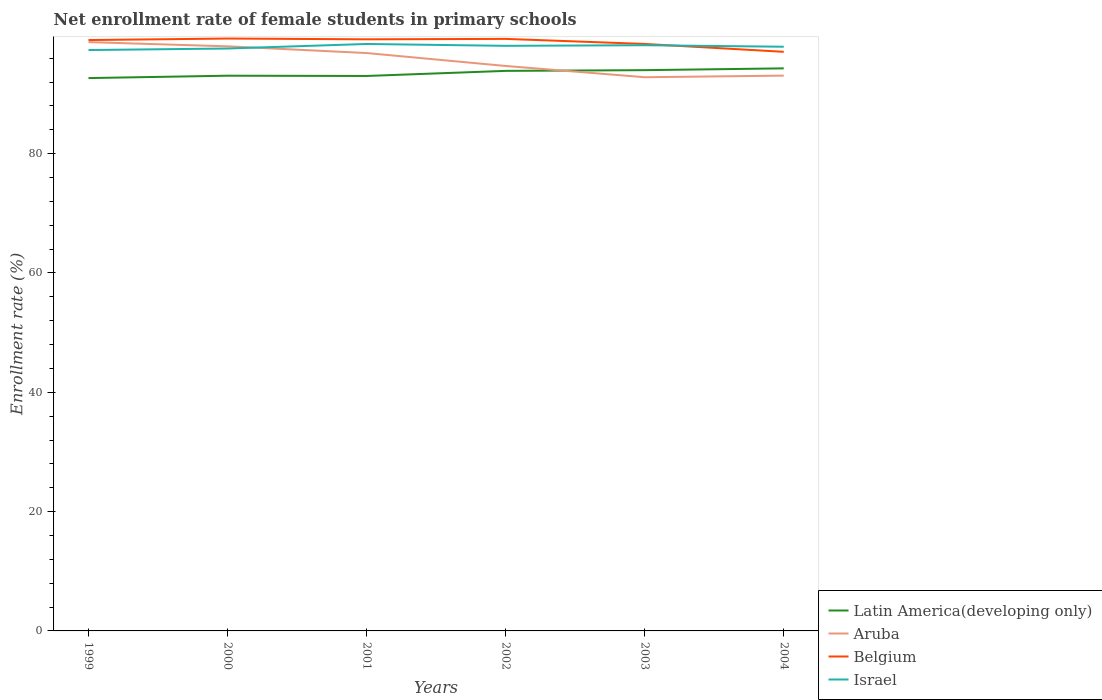How many different coloured lines are there?
Your response must be concise. 4. Does the line corresponding to Latin America(developing only) intersect with the line corresponding to Israel?
Keep it short and to the point. No. Across all years, what is the maximum net enrollment rate of female students in primary schools in Israel?
Make the answer very short. 97.37. What is the total net enrollment rate of female students in primary schools in Israel in the graph?
Provide a short and direct response. 0.31. What is the difference between the highest and the second highest net enrollment rate of female students in primary schools in Aruba?
Your response must be concise. 5.89. Is the net enrollment rate of female students in primary schools in Latin America(developing only) strictly greater than the net enrollment rate of female students in primary schools in Belgium over the years?
Offer a terse response. Yes. How many lines are there?
Offer a terse response. 4. What is the difference between two consecutive major ticks on the Y-axis?
Offer a terse response. 20. Does the graph contain grids?
Make the answer very short. No. Where does the legend appear in the graph?
Ensure brevity in your answer.  Bottom right. How are the legend labels stacked?
Give a very brief answer. Vertical. What is the title of the graph?
Provide a succinct answer. Net enrollment rate of female students in primary schools. What is the label or title of the X-axis?
Keep it short and to the point. Years. What is the label or title of the Y-axis?
Provide a short and direct response. Enrollment rate (%). What is the Enrollment rate (%) in Latin America(developing only) in 1999?
Your answer should be compact. 92.67. What is the Enrollment rate (%) in Aruba in 1999?
Your answer should be very brief. 98.7. What is the Enrollment rate (%) of Belgium in 1999?
Provide a succinct answer. 99.04. What is the Enrollment rate (%) of Israel in 1999?
Your answer should be very brief. 97.37. What is the Enrollment rate (%) of Latin America(developing only) in 2000?
Your answer should be very brief. 93.07. What is the Enrollment rate (%) of Aruba in 2000?
Provide a short and direct response. 97.99. What is the Enrollment rate (%) of Belgium in 2000?
Ensure brevity in your answer.  99.3. What is the Enrollment rate (%) of Israel in 2000?
Offer a very short reply. 97.63. What is the Enrollment rate (%) in Latin America(developing only) in 2001?
Offer a very short reply. 93.02. What is the Enrollment rate (%) of Aruba in 2001?
Your answer should be compact. 96.87. What is the Enrollment rate (%) in Belgium in 2001?
Provide a short and direct response. 99.17. What is the Enrollment rate (%) of Israel in 2001?
Give a very brief answer. 98.39. What is the Enrollment rate (%) of Latin America(developing only) in 2002?
Provide a short and direct response. 93.88. What is the Enrollment rate (%) of Aruba in 2002?
Offer a very short reply. 94.7. What is the Enrollment rate (%) of Belgium in 2002?
Keep it short and to the point. 99.24. What is the Enrollment rate (%) of Israel in 2002?
Your answer should be very brief. 98.08. What is the Enrollment rate (%) in Latin America(developing only) in 2003?
Give a very brief answer. 94. What is the Enrollment rate (%) of Aruba in 2003?
Provide a succinct answer. 92.81. What is the Enrollment rate (%) of Belgium in 2003?
Your answer should be very brief. 98.39. What is the Enrollment rate (%) of Israel in 2003?
Provide a succinct answer. 98.18. What is the Enrollment rate (%) in Latin America(developing only) in 2004?
Ensure brevity in your answer.  94.3. What is the Enrollment rate (%) of Aruba in 2004?
Make the answer very short. 93.08. What is the Enrollment rate (%) in Belgium in 2004?
Give a very brief answer. 97.07. What is the Enrollment rate (%) in Israel in 2004?
Provide a succinct answer. 97.93. Across all years, what is the maximum Enrollment rate (%) in Latin America(developing only)?
Give a very brief answer. 94.3. Across all years, what is the maximum Enrollment rate (%) of Aruba?
Ensure brevity in your answer.  98.7. Across all years, what is the maximum Enrollment rate (%) in Belgium?
Give a very brief answer. 99.3. Across all years, what is the maximum Enrollment rate (%) in Israel?
Provide a succinct answer. 98.39. Across all years, what is the minimum Enrollment rate (%) of Latin America(developing only)?
Offer a terse response. 92.67. Across all years, what is the minimum Enrollment rate (%) in Aruba?
Give a very brief answer. 92.81. Across all years, what is the minimum Enrollment rate (%) in Belgium?
Make the answer very short. 97.07. Across all years, what is the minimum Enrollment rate (%) in Israel?
Your answer should be very brief. 97.37. What is the total Enrollment rate (%) of Latin America(developing only) in the graph?
Offer a very short reply. 560.94. What is the total Enrollment rate (%) in Aruba in the graph?
Offer a very short reply. 574.16. What is the total Enrollment rate (%) in Belgium in the graph?
Ensure brevity in your answer.  592.21. What is the total Enrollment rate (%) of Israel in the graph?
Keep it short and to the point. 587.56. What is the difference between the Enrollment rate (%) of Latin America(developing only) in 1999 and that in 2000?
Your response must be concise. -0.4. What is the difference between the Enrollment rate (%) of Aruba in 1999 and that in 2000?
Keep it short and to the point. 0.71. What is the difference between the Enrollment rate (%) of Belgium in 1999 and that in 2000?
Your answer should be very brief. -0.25. What is the difference between the Enrollment rate (%) in Israel in 1999 and that in 2000?
Give a very brief answer. -0.26. What is the difference between the Enrollment rate (%) in Latin America(developing only) in 1999 and that in 2001?
Offer a terse response. -0.35. What is the difference between the Enrollment rate (%) of Aruba in 1999 and that in 2001?
Ensure brevity in your answer.  1.83. What is the difference between the Enrollment rate (%) in Belgium in 1999 and that in 2001?
Provide a succinct answer. -0.12. What is the difference between the Enrollment rate (%) in Israel in 1999 and that in 2001?
Make the answer very short. -1.02. What is the difference between the Enrollment rate (%) of Latin America(developing only) in 1999 and that in 2002?
Give a very brief answer. -1.21. What is the difference between the Enrollment rate (%) in Aruba in 1999 and that in 2002?
Your answer should be compact. 4. What is the difference between the Enrollment rate (%) of Belgium in 1999 and that in 2002?
Offer a very short reply. -0.19. What is the difference between the Enrollment rate (%) in Israel in 1999 and that in 2002?
Offer a terse response. -0.71. What is the difference between the Enrollment rate (%) in Latin America(developing only) in 1999 and that in 2003?
Give a very brief answer. -1.33. What is the difference between the Enrollment rate (%) of Aruba in 1999 and that in 2003?
Offer a very short reply. 5.89. What is the difference between the Enrollment rate (%) in Belgium in 1999 and that in 2003?
Ensure brevity in your answer.  0.65. What is the difference between the Enrollment rate (%) of Israel in 1999 and that in 2003?
Provide a succinct answer. -0.81. What is the difference between the Enrollment rate (%) of Latin America(developing only) in 1999 and that in 2004?
Keep it short and to the point. -1.63. What is the difference between the Enrollment rate (%) of Aruba in 1999 and that in 2004?
Provide a short and direct response. 5.62. What is the difference between the Enrollment rate (%) of Belgium in 1999 and that in 2004?
Provide a short and direct response. 1.97. What is the difference between the Enrollment rate (%) in Israel in 1999 and that in 2004?
Make the answer very short. -0.56. What is the difference between the Enrollment rate (%) of Latin America(developing only) in 2000 and that in 2001?
Your answer should be very brief. 0.05. What is the difference between the Enrollment rate (%) of Aruba in 2000 and that in 2001?
Offer a very short reply. 1.13. What is the difference between the Enrollment rate (%) in Belgium in 2000 and that in 2001?
Your answer should be compact. 0.13. What is the difference between the Enrollment rate (%) of Israel in 2000 and that in 2001?
Provide a succinct answer. -0.76. What is the difference between the Enrollment rate (%) of Latin America(developing only) in 2000 and that in 2002?
Provide a succinct answer. -0.81. What is the difference between the Enrollment rate (%) in Aruba in 2000 and that in 2002?
Provide a short and direct response. 3.29. What is the difference between the Enrollment rate (%) of Belgium in 2000 and that in 2002?
Your answer should be compact. 0.06. What is the difference between the Enrollment rate (%) in Israel in 2000 and that in 2002?
Give a very brief answer. -0.45. What is the difference between the Enrollment rate (%) in Latin America(developing only) in 2000 and that in 2003?
Keep it short and to the point. -0.93. What is the difference between the Enrollment rate (%) in Aruba in 2000 and that in 2003?
Your answer should be compact. 5.18. What is the difference between the Enrollment rate (%) of Belgium in 2000 and that in 2003?
Make the answer very short. 0.91. What is the difference between the Enrollment rate (%) in Israel in 2000 and that in 2003?
Your answer should be compact. -0.55. What is the difference between the Enrollment rate (%) of Latin America(developing only) in 2000 and that in 2004?
Give a very brief answer. -1.23. What is the difference between the Enrollment rate (%) of Aruba in 2000 and that in 2004?
Your response must be concise. 4.91. What is the difference between the Enrollment rate (%) of Belgium in 2000 and that in 2004?
Provide a succinct answer. 2.22. What is the difference between the Enrollment rate (%) in Israel in 2000 and that in 2004?
Ensure brevity in your answer.  -0.3. What is the difference between the Enrollment rate (%) in Latin America(developing only) in 2001 and that in 2002?
Offer a terse response. -0.85. What is the difference between the Enrollment rate (%) of Aruba in 2001 and that in 2002?
Make the answer very short. 2.17. What is the difference between the Enrollment rate (%) in Belgium in 2001 and that in 2002?
Offer a very short reply. -0.07. What is the difference between the Enrollment rate (%) in Israel in 2001 and that in 2002?
Make the answer very short. 0.31. What is the difference between the Enrollment rate (%) in Latin America(developing only) in 2001 and that in 2003?
Ensure brevity in your answer.  -0.98. What is the difference between the Enrollment rate (%) of Aruba in 2001 and that in 2003?
Your response must be concise. 4.05. What is the difference between the Enrollment rate (%) in Belgium in 2001 and that in 2003?
Give a very brief answer. 0.78. What is the difference between the Enrollment rate (%) of Israel in 2001 and that in 2003?
Your answer should be very brief. 0.21. What is the difference between the Enrollment rate (%) of Latin America(developing only) in 2001 and that in 2004?
Provide a succinct answer. -1.27. What is the difference between the Enrollment rate (%) of Aruba in 2001 and that in 2004?
Your answer should be compact. 3.78. What is the difference between the Enrollment rate (%) of Belgium in 2001 and that in 2004?
Make the answer very short. 2.1. What is the difference between the Enrollment rate (%) in Israel in 2001 and that in 2004?
Provide a short and direct response. 0.46. What is the difference between the Enrollment rate (%) in Latin America(developing only) in 2002 and that in 2003?
Your answer should be compact. -0.12. What is the difference between the Enrollment rate (%) in Aruba in 2002 and that in 2003?
Your answer should be very brief. 1.89. What is the difference between the Enrollment rate (%) in Belgium in 2002 and that in 2003?
Give a very brief answer. 0.85. What is the difference between the Enrollment rate (%) in Israel in 2002 and that in 2003?
Offer a terse response. -0.1. What is the difference between the Enrollment rate (%) in Latin America(developing only) in 2002 and that in 2004?
Offer a terse response. -0.42. What is the difference between the Enrollment rate (%) in Aruba in 2002 and that in 2004?
Offer a very short reply. 1.62. What is the difference between the Enrollment rate (%) of Belgium in 2002 and that in 2004?
Make the answer very short. 2.17. What is the difference between the Enrollment rate (%) in Israel in 2002 and that in 2004?
Your answer should be compact. 0.15. What is the difference between the Enrollment rate (%) of Latin America(developing only) in 2003 and that in 2004?
Your response must be concise. -0.3. What is the difference between the Enrollment rate (%) of Aruba in 2003 and that in 2004?
Make the answer very short. -0.27. What is the difference between the Enrollment rate (%) of Belgium in 2003 and that in 2004?
Offer a very short reply. 1.32. What is the difference between the Enrollment rate (%) in Israel in 2003 and that in 2004?
Offer a very short reply. 0.25. What is the difference between the Enrollment rate (%) of Latin America(developing only) in 1999 and the Enrollment rate (%) of Aruba in 2000?
Provide a short and direct response. -5.32. What is the difference between the Enrollment rate (%) in Latin America(developing only) in 1999 and the Enrollment rate (%) in Belgium in 2000?
Your answer should be very brief. -6.62. What is the difference between the Enrollment rate (%) of Latin America(developing only) in 1999 and the Enrollment rate (%) of Israel in 2000?
Your answer should be very brief. -4.96. What is the difference between the Enrollment rate (%) of Aruba in 1999 and the Enrollment rate (%) of Belgium in 2000?
Your response must be concise. -0.6. What is the difference between the Enrollment rate (%) in Aruba in 1999 and the Enrollment rate (%) in Israel in 2000?
Make the answer very short. 1.07. What is the difference between the Enrollment rate (%) in Belgium in 1999 and the Enrollment rate (%) in Israel in 2000?
Provide a succinct answer. 1.42. What is the difference between the Enrollment rate (%) in Latin America(developing only) in 1999 and the Enrollment rate (%) in Aruba in 2001?
Ensure brevity in your answer.  -4.2. What is the difference between the Enrollment rate (%) of Latin America(developing only) in 1999 and the Enrollment rate (%) of Belgium in 2001?
Provide a succinct answer. -6.5. What is the difference between the Enrollment rate (%) of Latin America(developing only) in 1999 and the Enrollment rate (%) of Israel in 2001?
Make the answer very short. -5.72. What is the difference between the Enrollment rate (%) in Aruba in 1999 and the Enrollment rate (%) in Belgium in 2001?
Make the answer very short. -0.47. What is the difference between the Enrollment rate (%) in Aruba in 1999 and the Enrollment rate (%) in Israel in 2001?
Your answer should be very brief. 0.31. What is the difference between the Enrollment rate (%) in Belgium in 1999 and the Enrollment rate (%) in Israel in 2001?
Your response must be concise. 0.66. What is the difference between the Enrollment rate (%) of Latin America(developing only) in 1999 and the Enrollment rate (%) of Aruba in 2002?
Offer a terse response. -2.03. What is the difference between the Enrollment rate (%) in Latin America(developing only) in 1999 and the Enrollment rate (%) in Belgium in 2002?
Your answer should be very brief. -6.57. What is the difference between the Enrollment rate (%) of Latin America(developing only) in 1999 and the Enrollment rate (%) of Israel in 2002?
Your response must be concise. -5.4. What is the difference between the Enrollment rate (%) in Aruba in 1999 and the Enrollment rate (%) in Belgium in 2002?
Your response must be concise. -0.54. What is the difference between the Enrollment rate (%) of Aruba in 1999 and the Enrollment rate (%) of Israel in 2002?
Offer a terse response. 0.62. What is the difference between the Enrollment rate (%) in Belgium in 1999 and the Enrollment rate (%) in Israel in 2002?
Make the answer very short. 0.97. What is the difference between the Enrollment rate (%) in Latin America(developing only) in 1999 and the Enrollment rate (%) in Aruba in 2003?
Offer a very short reply. -0.14. What is the difference between the Enrollment rate (%) of Latin America(developing only) in 1999 and the Enrollment rate (%) of Belgium in 2003?
Provide a short and direct response. -5.72. What is the difference between the Enrollment rate (%) in Latin America(developing only) in 1999 and the Enrollment rate (%) in Israel in 2003?
Your answer should be compact. -5.51. What is the difference between the Enrollment rate (%) of Aruba in 1999 and the Enrollment rate (%) of Belgium in 2003?
Offer a very short reply. 0.31. What is the difference between the Enrollment rate (%) in Aruba in 1999 and the Enrollment rate (%) in Israel in 2003?
Provide a succinct answer. 0.52. What is the difference between the Enrollment rate (%) in Belgium in 1999 and the Enrollment rate (%) in Israel in 2003?
Offer a very short reply. 0.87. What is the difference between the Enrollment rate (%) of Latin America(developing only) in 1999 and the Enrollment rate (%) of Aruba in 2004?
Give a very brief answer. -0.41. What is the difference between the Enrollment rate (%) in Latin America(developing only) in 1999 and the Enrollment rate (%) in Belgium in 2004?
Give a very brief answer. -4.4. What is the difference between the Enrollment rate (%) of Latin America(developing only) in 1999 and the Enrollment rate (%) of Israel in 2004?
Offer a very short reply. -5.25. What is the difference between the Enrollment rate (%) of Aruba in 1999 and the Enrollment rate (%) of Belgium in 2004?
Provide a short and direct response. 1.63. What is the difference between the Enrollment rate (%) of Aruba in 1999 and the Enrollment rate (%) of Israel in 2004?
Make the answer very short. 0.77. What is the difference between the Enrollment rate (%) in Belgium in 1999 and the Enrollment rate (%) in Israel in 2004?
Make the answer very short. 1.12. What is the difference between the Enrollment rate (%) of Latin America(developing only) in 2000 and the Enrollment rate (%) of Aruba in 2001?
Ensure brevity in your answer.  -3.8. What is the difference between the Enrollment rate (%) in Latin America(developing only) in 2000 and the Enrollment rate (%) in Belgium in 2001?
Provide a short and direct response. -6.1. What is the difference between the Enrollment rate (%) in Latin America(developing only) in 2000 and the Enrollment rate (%) in Israel in 2001?
Your answer should be compact. -5.32. What is the difference between the Enrollment rate (%) of Aruba in 2000 and the Enrollment rate (%) of Belgium in 2001?
Ensure brevity in your answer.  -1.18. What is the difference between the Enrollment rate (%) of Aruba in 2000 and the Enrollment rate (%) of Israel in 2001?
Offer a very short reply. -0.4. What is the difference between the Enrollment rate (%) of Belgium in 2000 and the Enrollment rate (%) of Israel in 2001?
Keep it short and to the point. 0.91. What is the difference between the Enrollment rate (%) of Latin America(developing only) in 2000 and the Enrollment rate (%) of Aruba in 2002?
Your answer should be very brief. -1.63. What is the difference between the Enrollment rate (%) in Latin America(developing only) in 2000 and the Enrollment rate (%) in Belgium in 2002?
Give a very brief answer. -6.17. What is the difference between the Enrollment rate (%) of Latin America(developing only) in 2000 and the Enrollment rate (%) of Israel in 2002?
Your response must be concise. -5.01. What is the difference between the Enrollment rate (%) in Aruba in 2000 and the Enrollment rate (%) in Belgium in 2002?
Your answer should be compact. -1.25. What is the difference between the Enrollment rate (%) in Aruba in 2000 and the Enrollment rate (%) in Israel in 2002?
Provide a succinct answer. -0.08. What is the difference between the Enrollment rate (%) of Belgium in 2000 and the Enrollment rate (%) of Israel in 2002?
Give a very brief answer. 1.22. What is the difference between the Enrollment rate (%) in Latin America(developing only) in 2000 and the Enrollment rate (%) in Aruba in 2003?
Make the answer very short. 0.26. What is the difference between the Enrollment rate (%) in Latin America(developing only) in 2000 and the Enrollment rate (%) in Belgium in 2003?
Your response must be concise. -5.32. What is the difference between the Enrollment rate (%) of Latin America(developing only) in 2000 and the Enrollment rate (%) of Israel in 2003?
Make the answer very short. -5.11. What is the difference between the Enrollment rate (%) of Aruba in 2000 and the Enrollment rate (%) of Belgium in 2003?
Your answer should be very brief. -0.4. What is the difference between the Enrollment rate (%) of Aruba in 2000 and the Enrollment rate (%) of Israel in 2003?
Provide a succinct answer. -0.18. What is the difference between the Enrollment rate (%) of Belgium in 2000 and the Enrollment rate (%) of Israel in 2003?
Give a very brief answer. 1.12. What is the difference between the Enrollment rate (%) in Latin America(developing only) in 2000 and the Enrollment rate (%) in Aruba in 2004?
Ensure brevity in your answer.  -0.02. What is the difference between the Enrollment rate (%) of Latin America(developing only) in 2000 and the Enrollment rate (%) of Belgium in 2004?
Your answer should be very brief. -4. What is the difference between the Enrollment rate (%) of Latin America(developing only) in 2000 and the Enrollment rate (%) of Israel in 2004?
Your answer should be compact. -4.86. What is the difference between the Enrollment rate (%) of Aruba in 2000 and the Enrollment rate (%) of Belgium in 2004?
Offer a terse response. 0.92. What is the difference between the Enrollment rate (%) of Aruba in 2000 and the Enrollment rate (%) of Israel in 2004?
Offer a very short reply. 0.07. What is the difference between the Enrollment rate (%) of Belgium in 2000 and the Enrollment rate (%) of Israel in 2004?
Make the answer very short. 1.37. What is the difference between the Enrollment rate (%) in Latin America(developing only) in 2001 and the Enrollment rate (%) in Aruba in 2002?
Provide a short and direct response. -1.68. What is the difference between the Enrollment rate (%) in Latin America(developing only) in 2001 and the Enrollment rate (%) in Belgium in 2002?
Your response must be concise. -6.22. What is the difference between the Enrollment rate (%) of Latin America(developing only) in 2001 and the Enrollment rate (%) of Israel in 2002?
Your answer should be compact. -5.05. What is the difference between the Enrollment rate (%) in Aruba in 2001 and the Enrollment rate (%) in Belgium in 2002?
Your answer should be very brief. -2.37. What is the difference between the Enrollment rate (%) of Aruba in 2001 and the Enrollment rate (%) of Israel in 2002?
Provide a short and direct response. -1.21. What is the difference between the Enrollment rate (%) of Belgium in 2001 and the Enrollment rate (%) of Israel in 2002?
Your response must be concise. 1.09. What is the difference between the Enrollment rate (%) of Latin America(developing only) in 2001 and the Enrollment rate (%) of Aruba in 2003?
Make the answer very short. 0.21. What is the difference between the Enrollment rate (%) of Latin America(developing only) in 2001 and the Enrollment rate (%) of Belgium in 2003?
Keep it short and to the point. -5.37. What is the difference between the Enrollment rate (%) in Latin America(developing only) in 2001 and the Enrollment rate (%) in Israel in 2003?
Your answer should be compact. -5.15. What is the difference between the Enrollment rate (%) of Aruba in 2001 and the Enrollment rate (%) of Belgium in 2003?
Provide a succinct answer. -1.52. What is the difference between the Enrollment rate (%) of Aruba in 2001 and the Enrollment rate (%) of Israel in 2003?
Offer a terse response. -1.31. What is the difference between the Enrollment rate (%) in Latin America(developing only) in 2001 and the Enrollment rate (%) in Aruba in 2004?
Offer a very short reply. -0.06. What is the difference between the Enrollment rate (%) of Latin America(developing only) in 2001 and the Enrollment rate (%) of Belgium in 2004?
Offer a terse response. -4.05. What is the difference between the Enrollment rate (%) in Latin America(developing only) in 2001 and the Enrollment rate (%) in Israel in 2004?
Your response must be concise. -4.9. What is the difference between the Enrollment rate (%) in Aruba in 2001 and the Enrollment rate (%) in Belgium in 2004?
Your response must be concise. -0.21. What is the difference between the Enrollment rate (%) in Aruba in 2001 and the Enrollment rate (%) in Israel in 2004?
Give a very brief answer. -1.06. What is the difference between the Enrollment rate (%) of Belgium in 2001 and the Enrollment rate (%) of Israel in 2004?
Offer a very short reply. 1.24. What is the difference between the Enrollment rate (%) of Latin America(developing only) in 2002 and the Enrollment rate (%) of Aruba in 2003?
Keep it short and to the point. 1.06. What is the difference between the Enrollment rate (%) in Latin America(developing only) in 2002 and the Enrollment rate (%) in Belgium in 2003?
Your response must be concise. -4.51. What is the difference between the Enrollment rate (%) of Latin America(developing only) in 2002 and the Enrollment rate (%) of Israel in 2003?
Your response must be concise. -4.3. What is the difference between the Enrollment rate (%) of Aruba in 2002 and the Enrollment rate (%) of Belgium in 2003?
Your answer should be compact. -3.69. What is the difference between the Enrollment rate (%) of Aruba in 2002 and the Enrollment rate (%) of Israel in 2003?
Ensure brevity in your answer.  -3.48. What is the difference between the Enrollment rate (%) of Belgium in 2002 and the Enrollment rate (%) of Israel in 2003?
Make the answer very short. 1.06. What is the difference between the Enrollment rate (%) in Latin America(developing only) in 2002 and the Enrollment rate (%) in Aruba in 2004?
Offer a very short reply. 0.79. What is the difference between the Enrollment rate (%) in Latin America(developing only) in 2002 and the Enrollment rate (%) in Belgium in 2004?
Provide a short and direct response. -3.2. What is the difference between the Enrollment rate (%) in Latin America(developing only) in 2002 and the Enrollment rate (%) in Israel in 2004?
Your answer should be very brief. -4.05. What is the difference between the Enrollment rate (%) of Aruba in 2002 and the Enrollment rate (%) of Belgium in 2004?
Your answer should be compact. -2.37. What is the difference between the Enrollment rate (%) in Aruba in 2002 and the Enrollment rate (%) in Israel in 2004?
Offer a very short reply. -3.23. What is the difference between the Enrollment rate (%) of Belgium in 2002 and the Enrollment rate (%) of Israel in 2004?
Give a very brief answer. 1.31. What is the difference between the Enrollment rate (%) of Latin America(developing only) in 2003 and the Enrollment rate (%) of Aruba in 2004?
Your answer should be very brief. 0.91. What is the difference between the Enrollment rate (%) in Latin America(developing only) in 2003 and the Enrollment rate (%) in Belgium in 2004?
Make the answer very short. -3.07. What is the difference between the Enrollment rate (%) of Latin America(developing only) in 2003 and the Enrollment rate (%) of Israel in 2004?
Give a very brief answer. -3.93. What is the difference between the Enrollment rate (%) of Aruba in 2003 and the Enrollment rate (%) of Belgium in 2004?
Provide a succinct answer. -4.26. What is the difference between the Enrollment rate (%) in Aruba in 2003 and the Enrollment rate (%) in Israel in 2004?
Your answer should be compact. -5.11. What is the difference between the Enrollment rate (%) of Belgium in 2003 and the Enrollment rate (%) of Israel in 2004?
Your response must be concise. 0.46. What is the average Enrollment rate (%) in Latin America(developing only) per year?
Your response must be concise. 93.49. What is the average Enrollment rate (%) in Aruba per year?
Keep it short and to the point. 95.69. What is the average Enrollment rate (%) of Belgium per year?
Offer a terse response. 98.7. What is the average Enrollment rate (%) of Israel per year?
Offer a terse response. 97.93. In the year 1999, what is the difference between the Enrollment rate (%) in Latin America(developing only) and Enrollment rate (%) in Aruba?
Make the answer very short. -6.03. In the year 1999, what is the difference between the Enrollment rate (%) in Latin America(developing only) and Enrollment rate (%) in Belgium?
Your response must be concise. -6.37. In the year 1999, what is the difference between the Enrollment rate (%) in Latin America(developing only) and Enrollment rate (%) in Israel?
Offer a very short reply. -4.7. In the year 1999, what is the difference between the Enrollment rate (%) of Aruba and Enrollment rate (%) of Belgium?
Provide a short and direct response. -0.35. In the year 1999, what is the difference between the Enrollment rate (%) of Aruba and Enrollment rate (%) of Israel?
Keep it short and to the point. 1.33. In the year 1999, what is the difference between the Enrollment rate (%) in Belgium and Enrollment rate (%) in Israel?
Give a very brief answer. 1.68. In the year 2000, what is the difference between the Enrollment rate (%) of Latin America(developing only) and Enrollment rate (%) of Aruba?
Your answer should be compact. -4.92. In the year 2000, what is the difference between the Enrollment rate (%) of Latin America(developing only) and Enrollment rate (%) of Belgium?
Ensure brevity in your answer.  -6.23. In the year 2000, what is the difference between the Enrollment rate (%) of Latin America(developing only) and Enrollment rate (%) of Israel?
Give a very brief answer. -4.56. In the year 2000, what is the difference between the Enrollment rate (%) of Aruba and Enrollment rate (%) of Belgium?
Offer a very short reply. -1.3. In the year 2000, what is the difference between the Enrollment rate (%) of Aruba and Enrollment rate (%) of Israel?
Offer a terse response. 0.37. In the year 2000, what is the difference between the Enrollment rate (%) of Belgium and Enrollment rate (%) of Israel?
Provide a succinct answer. 1.67. In the year 2001, what is the difference between the Enrollment rate (%) in Latin America(developing only) and Enrollment rate (%) in Aruba?
Offer a very short reply. -3.84. In the year 2001, what is the difference between the Enrollment rate (%) in Latin America(developing only) and Enrollment rate (%) in Belgium?
Keep it short and to the point. -6.15. In the year 2001, what is the difference between the Enrollment rate (%) in Latin America(developing only) and Enrollment rate (%) in Israel?
Your answer should be very brief. -5.37. In the year 2001, what is the difference between the Enrollment rate (%) in Aruba and Enrollment rate (%) in Belgium?
Make the answer very short. -2.3. In the year 2001, what is the difference between the Enrollment rate (%) in Aruba and Enrollment rate (%) in Israel?
Your answer should be very brief. -1.52. In the year 2001, what is the difference between the Enrollment rate (%) in Belgium and Enrollment rate (%) in Israel?
Provide a short and direct response. 0.78. In the year 2002, what is the difference between the Enrollment rate (%) in Latin America(developing only) and Enrollment rate (%) in Aruba?
Provide a short and direct response. -0.82. In the year 2002, what is the difference between the Enrollment rate (%) of Latin America(developing only) and Enrollment rate (%) of Belgium?
Provide a short and direct response. -5.36. In the year 2002, what is the difference between the Enrollment rate (%) of Latin America(developing only) and Enrollment rate (%) of Israel?
Provide a short and direct response. -4.2. In the year 2002, what is the difference between the Enrollment rate (%) of Aruba and Enrollment rate (%) of Belgium?
Ensure brevity in your answer.  -4.54. In the year 2002, what is the difference between the Enrollment rate (%) of Aruba and Enrollment rate (%) of Israel?
Your answer should be compact. -3.38. In the year 2002, what is the difference between the Enrollment rate (%) of Belgium and Enrollment rate (%) of Israel?
Provide a short and direct response. 1.16. In the year 2003, what is the difference between the Enrollment rate (%) in Latin America(developing only) and Enrollment rate (%) in Aruba?
Offer a terse response. 1.19. In the year 2003, what is the difference between the Enrollment rate (%) in Latin America(developing only) and Enrollment rate (%) in Belgium?
Your response must be concise. -4.39. In the year 2003, what is the difference between the Enrollment rate (%) of Latin America(developing only) and Enrollment rate (%) of Israel?
Ensure brevity in your answer.  -4.18. In the year 2003, what is the difference between the Enrollment rate (%) of Aruba and Enrollment rate (%) of Belgium?
Your answer should be compact. -5.58. In the year 2003, what is the difference between the Enrollment rate (%) of Aruba and Enrollment rate (%) of Israel?
Your answer should be very brief. -5.36. In the year 2003, what is the difference between the Enrollment rate (%) of Belgium and Enrollment rate (%) of Israel?
Provide a short and direct response. 0.21. In the year 2004, what is the difference between the Enrollment rate (%) in Latin America(developing only) and Enrollment rate (%) in Aruba?
Offer a very short reply. 1.21. In the year 2004, what is the difference between the Enrollment rate (%) in Latin America(developing only) and Enrollment rate (%) in Belgium?
Ensure brevity in your answer.  -2.77. In the year 2004, what is the difference between the Enrollment rate (%) of Latin America(developing only) and Enrollment rate (%) of Israel?
Your response must be concise. -3.63. In the year 2004, what is the difference between the Enrollment rate (%) of Aruba and Enrollment rate (%) of Belgium?
Provide a short and direct response. -3.99. In the year 2004, what is the difference between the Enrollment rate (%) in Aruba and Enrollment rate (%) in Israel?
Your answer should be very brief. -4.84. In the year 2004, what is the difference between the Enrollment rate (%) in Belgium and Enrollment rate (%) in Israel?
Keep it short and to the point. -0.85. What is the ratio of the Enrollment rate (%) in Latin America(developing only) in 1999 to that in 2001?
Make the answer very short. 1. What is the ratio of the Enrollment rate (%) in Aruba in 1999 to that in 2001?
Provide a short and direct response. 1.02. What is the ratio of the Enrollment rate (%) in Latin America(developing only) in 1999 to that in 2002?
Provide a succinct answer. 0.99. What is the ratio of the Enrollment rate (%) in Aruba in 1999 to that in 2002?
Provide a succinct answer. 1.04. What is the ratio of the Enrollment rate (%) in Belgium in 1999 to that in 2002?
Your response must be concise. 1. What is the ratio of the Enrollment rate (%) in Israel in 1999 to that in 2002?
Offer a very short reply. 0.99. What is the ratio of the Enrollment rate (%) in Latin America(developing only) in 1999 to that in 2003?
Your answer should be compact. 0.99. What is the ratio of the Enrollment rate (%) in Aruba in 1999 to that in 2003?
Provide a succinct answer. 1.06. What is the ratio of the Enrollment rate (%) of Israel in 1999 to that in 2003?
Ensure brevity in your answer.  0.99. What is the ratio of the Enrollment rate (%) in Latin America(developing only) in 1999 to that in 2004?
Make the answer very short. 0.98. What is the ratio of the Enrollment rate (%) in Aruba in 1999 to that in 2004?
Your answer should be very brief. 1.06. What is the ratio of the Enrollment rate (%) of Belgium in 1999 to that in 2004?
Make the answer very short. 1.02. What is the ratio of the Enrollment rate (%) in Aruba in 2000 to that in 2001?
Provide a succinct answer. 1.01. What is the ratio of the Enrollment rate (%) of Latin America(developing only) in 2000 to that in 2002?
Keep it short and to the point. 0.99. What is the ratio of the Enrollment rate (%) of Aruba in 2000 to that in 2002?
Provide a short and direct response. 1.03. What is the ratio of the Enrollment rate (%) in Latin America(developing only) in 2000 to that in 2003?
Offer a very short reply. 0.99. What is the ratio of the Enrollment rate (%) in Aruba in 2000 to that in 2003?
Your answer should be very brief. 1.06. What is the ratio of the Enrollment rate (%) of Belgium in 2000 to that in 2003?
Make the answer very short. 1.01. What is the ratio of the Enrollment rate (%) in Latin America(developing only) in 2000 to that in 2004?
Your response must be concise. 0.99. What is the ratio of the Enrollment rate (%) of Aruba in 2000 to that in 2004?
Offer a terse response. 1.05. What is the ratio of the Enrollment rate (%) in Belgium in 2000 to that in 2004?
Offer a terse response. 1.02. What is the ratio of the Enrollment rate (%) in Latin America(developing only) in 2001 to that in 2002?
Give a very brief answer. 0.99. What is the ratio of the Enrollment rate (%) in Aruba in 2001 to that in 2002?
Your answer should be compact. 1.02. What is the ratio of the Enrollment rate (%) in Belgium in 2001 to that in 2002?
Your answer should be compact. 1. What is the ratio of the Enrollment rate (%) of Israel in 2001 to that in 2002?
Ensure brevity in your answer.  1. What is the ratio of the Enrollment rate (%) of Latin America(developing only) in 2001 to that in 2003?
Provide a short and direct response. 0.99. What is the ratio of the Enrollment rate (%) of Aruba in 2001 to that in 2003?
Provide a short and direct response. 1.04. What is the ratio of the Enrollment rate (%) in Belgium in 2001 to that in 2003?
Give a very brief answer. 1.01. What is the ratio of the Enrollment rate (%) of Latin America(developing only) in 2001 to that in 2004?
Your answer should be very brief. 0.99. What is the ratio of the Enrollment rate (%) in Aruba in 2001 to that in 2004?
Provide a succinct answer. 1.04. What is the ratio of the Enrollment rate (%) of Belgium in 2001 to that in 2004?
Provide a succinct answer. 1.02. What is the ratio of the Enrollment rate (%) in Latin America(developing only) in 2002 to that in 2003?
Ensure brevity in your answer.  1. What is the ratio of the Enrollment rate (%) in Aruba in 2002 to that in 2003?
Your answer should be compact. 1.02. What is the ratio of the Enrollment rate (%) of Belgium in 2002 to that in 2003?
Offer a terse response. 1.01. What is the ratio of the Enrollment rate (%) of Latin America(developing only) in 2002 to that in 2004?
Offer a very short reply. 1. What is the ratio of the Enrollment rate (%) of Aruba in 2002 to that in 2004?
Your response must be concise. 1.02. What is the ratio of the Enrollment rate (%) of Belgium in 2002 to that in 2004?
Provide a short and direct response. 1.02. What is the ratio of the Enrollment rate (%) in Aruba in 2003 to that in 2004?
Your answer should be very brief. 1. What is the ratio of the Enrollment rate (%) in Belgium in 2003 to that in 2004?
Offer a very short reply. 1.01. What is the ratio of the Enrollment rate (%) in Israel in 2003 to that in 2004?
Offer a terse response. 1. What is the difference between the highest and the second highest Enrollment rate (%) of Latin America(developing only)?
Make the answer very short. 0.3. What is the difference between the highest and the second highest Enrollment rate (%) in Aruba?
Keep it short and to the point. 0.71. What is the difference between the highest and the second highest Enrollment rate (%) in Belgium?
Your response must be concise. 0.06. What is the difference between the highest and the second highest Enrollment rate (%) of Israel?
Your answer should be compact. 0.21. What is the difference between the highest and the lowest Enrollment rate (%) in Latin America(developing only)?
Offer a terse response. 1.63. What is the difference between the highest and the lowest Enrollment rate (%) in Aruba?
Ensure brevity in your answer.  5.89. What is the difference between the highest and the lowest Enrollment rate (%) in Belgium?
Make the answer very short. 2.22. What is the difference between the highest and the lowest Enrollment rate (%) of Israel?
Your answer should be compact. 1.02. 